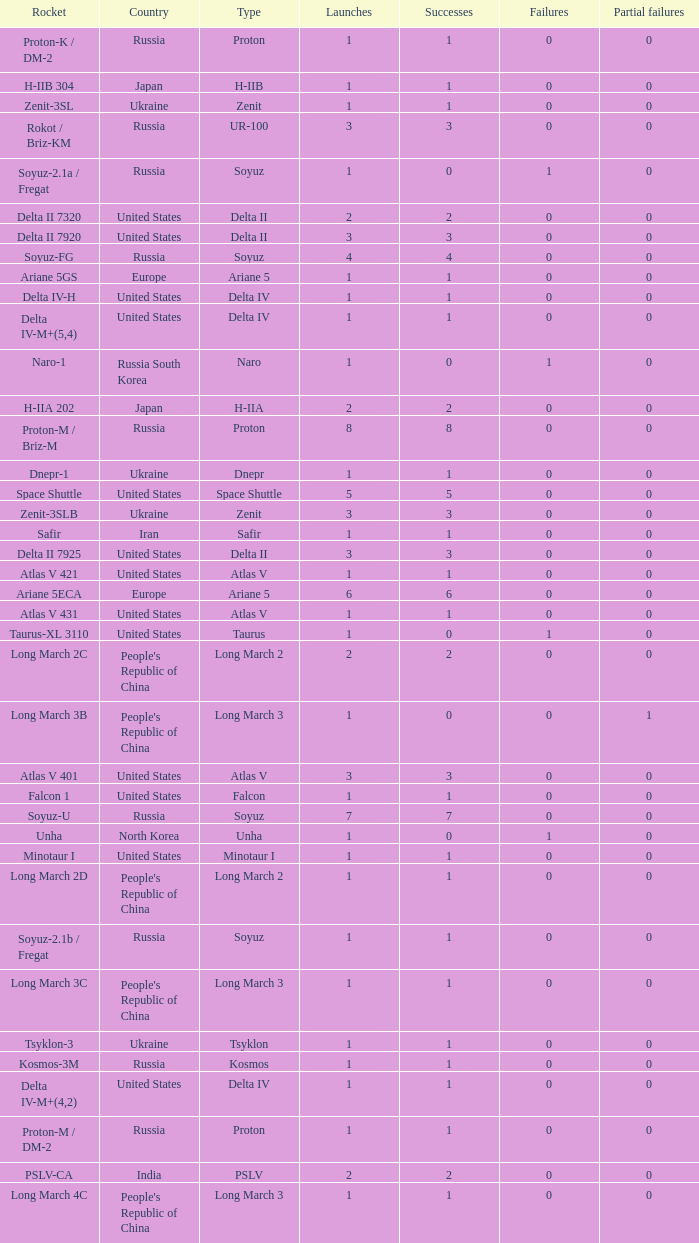What's the total failures among rockets that had more than 3 successes, type ariane 5 and more than 0 partial failures? 0.0. 